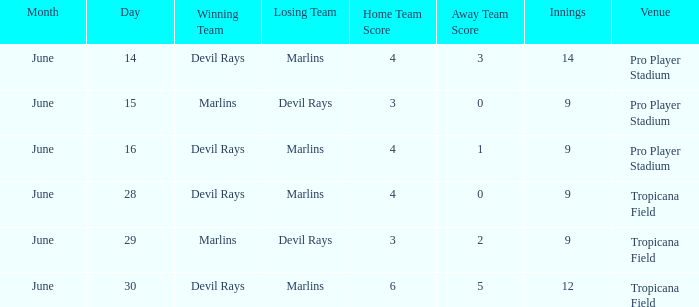Who won by a score of 4-1? Devil Rays. 